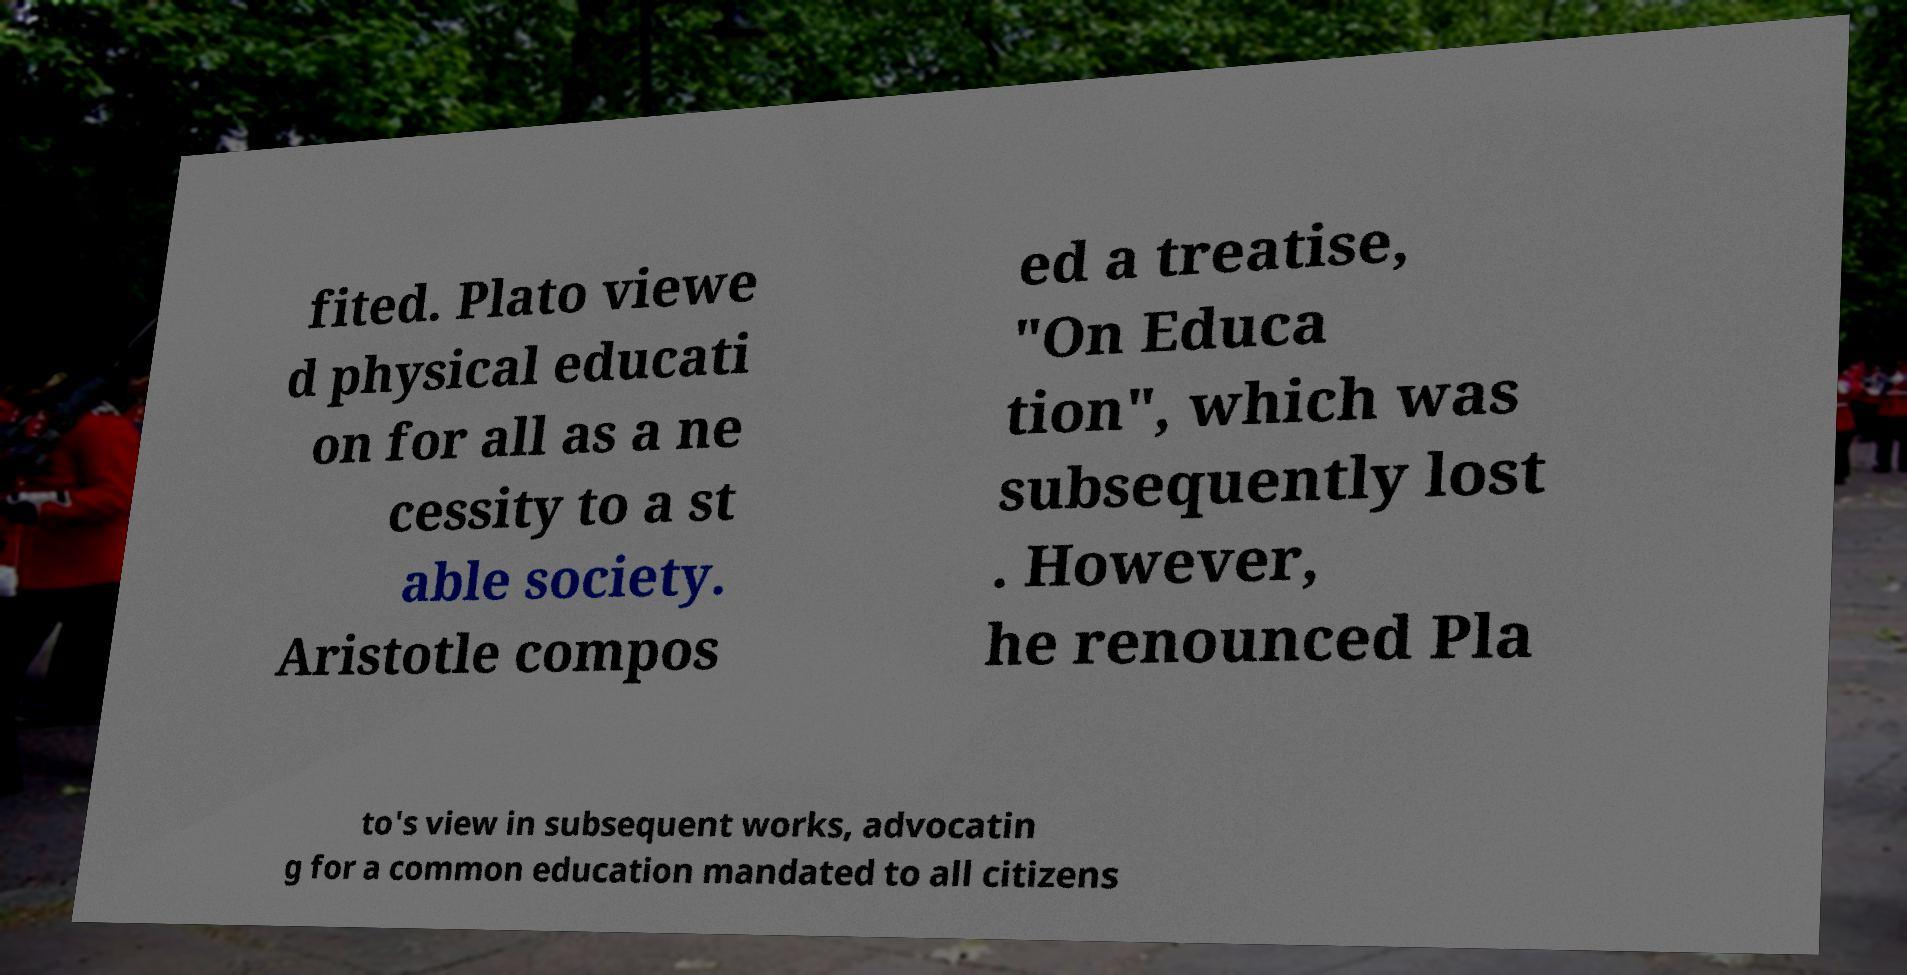Can you read and provide the text displayed in the image?This photo seems to have some interesting text. Can you extract and type it out for me? fited. Plato viewe d physical educati on for all as a ne cessity to a st able society. Aristotle compos ed a treatise, "On Educa tion", which was subsequently lost . However, he renounced Pla to's view in subsequent works, advocatin g for a common education mandated to all citizens 